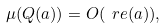<formula> <loc_0><loc_0><loc_500><loc_500>\mu ( Q ( a ) ) = O ( \ r e ( a ) ) ,</formula> 